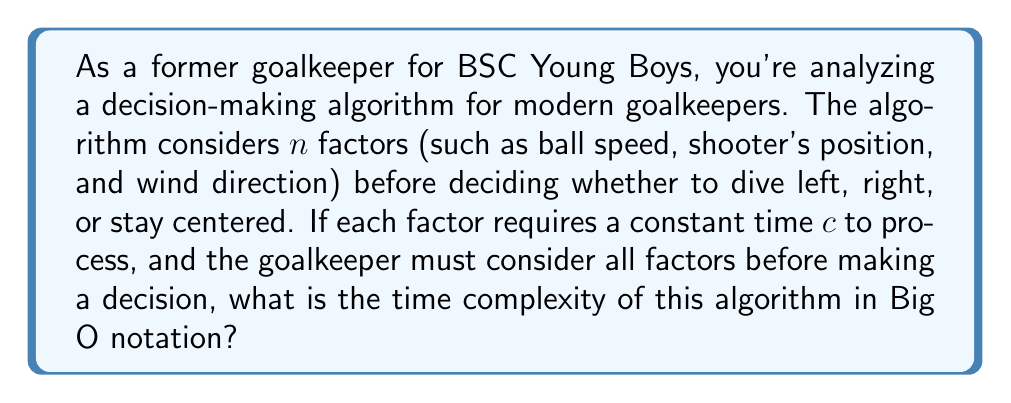Help me with this question. To analyze the time complexity of this algorithm, let's break it down step-by-step:

1. The algorithm considers $n$ factors.
2. Each factor takes a constant time $c$ to process.
3. All factors must be considered before making a decision.

Given these conditions:

1. The time to process each factor is constant: $O(c)$
2. This process is repeated for all $n$ factors.
3. The total time is therefore: $n \times O(c)$

In Big O notation, we ignore constant factors. So, $O(c)$ simplifies to $O(1)$.

Therefore, the total time complexity is:

$$n \times O(1) = O(n)$$

This is a linear time complexity, as the time taken increases linearly with the number of factors considered.

It's worth noting that this analysis assumes that the decision-making process after considering all factors is constant time, which is typically a reasonable assumption for a simple decision like choosing between three options (left, right, center).
Answer: $O(n)$ 